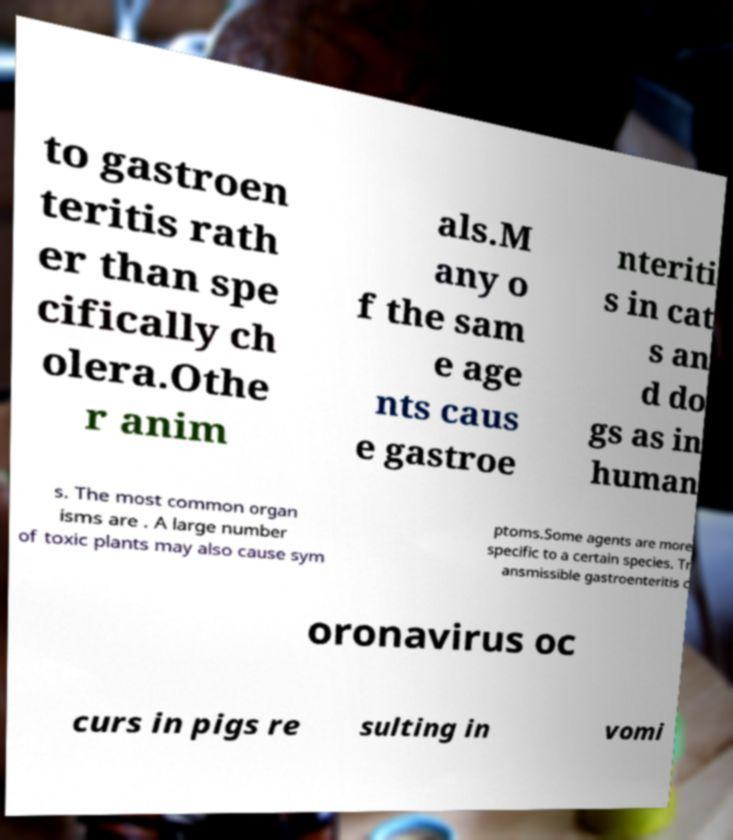What messages or text are displayed in this image? I need them in a readable, typed format. to gastroen teritis rath er than spe cifically ch olera.Othe r anim als.M any o f the sam e age nts caus e gastroe nteriti s in cat s an d do gs as in human s. The most common organ isms are . A large number of toxic plants may also cause sym ptoms.Some agents are more specific to a certain species. Tr ansmissible gastroenteritis c oronavirus oc curs in pigs re sulting in vomi 